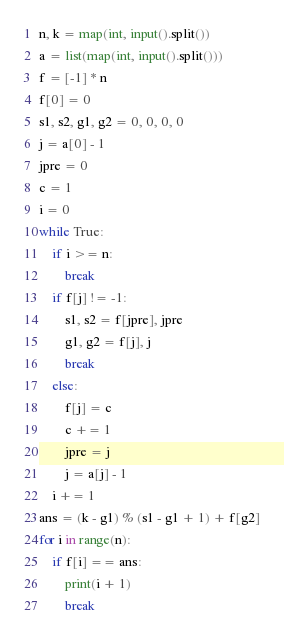Convert code to text. <code><loc_0><loc_0><loc_500><loc_500><_Python_>n, k = map(int, input().split())
a = list(map(int, input().split()))
f = [-1] * n
f[0] = 0
s1, s2, g1, g2 = 0, 0, 0, 0
j = a[0] - 1
jpre = 0
c = 1
i = 0
while True:
    if i >= n:
        break
    if f[j] != -1:
        s1, s2 = f[jpre], jpre
        g1, g2 = f[j], j
        break
    else:
        f[j] = c
        c += 1
        jpre = j
        j = a[j] - 1
    i += 1
ans = (k - g1) % (s1 - g1 + 1) + f[g2]
for i in range(n):
    if f[i] == ans:
        print(i + 1)
        break</code> 